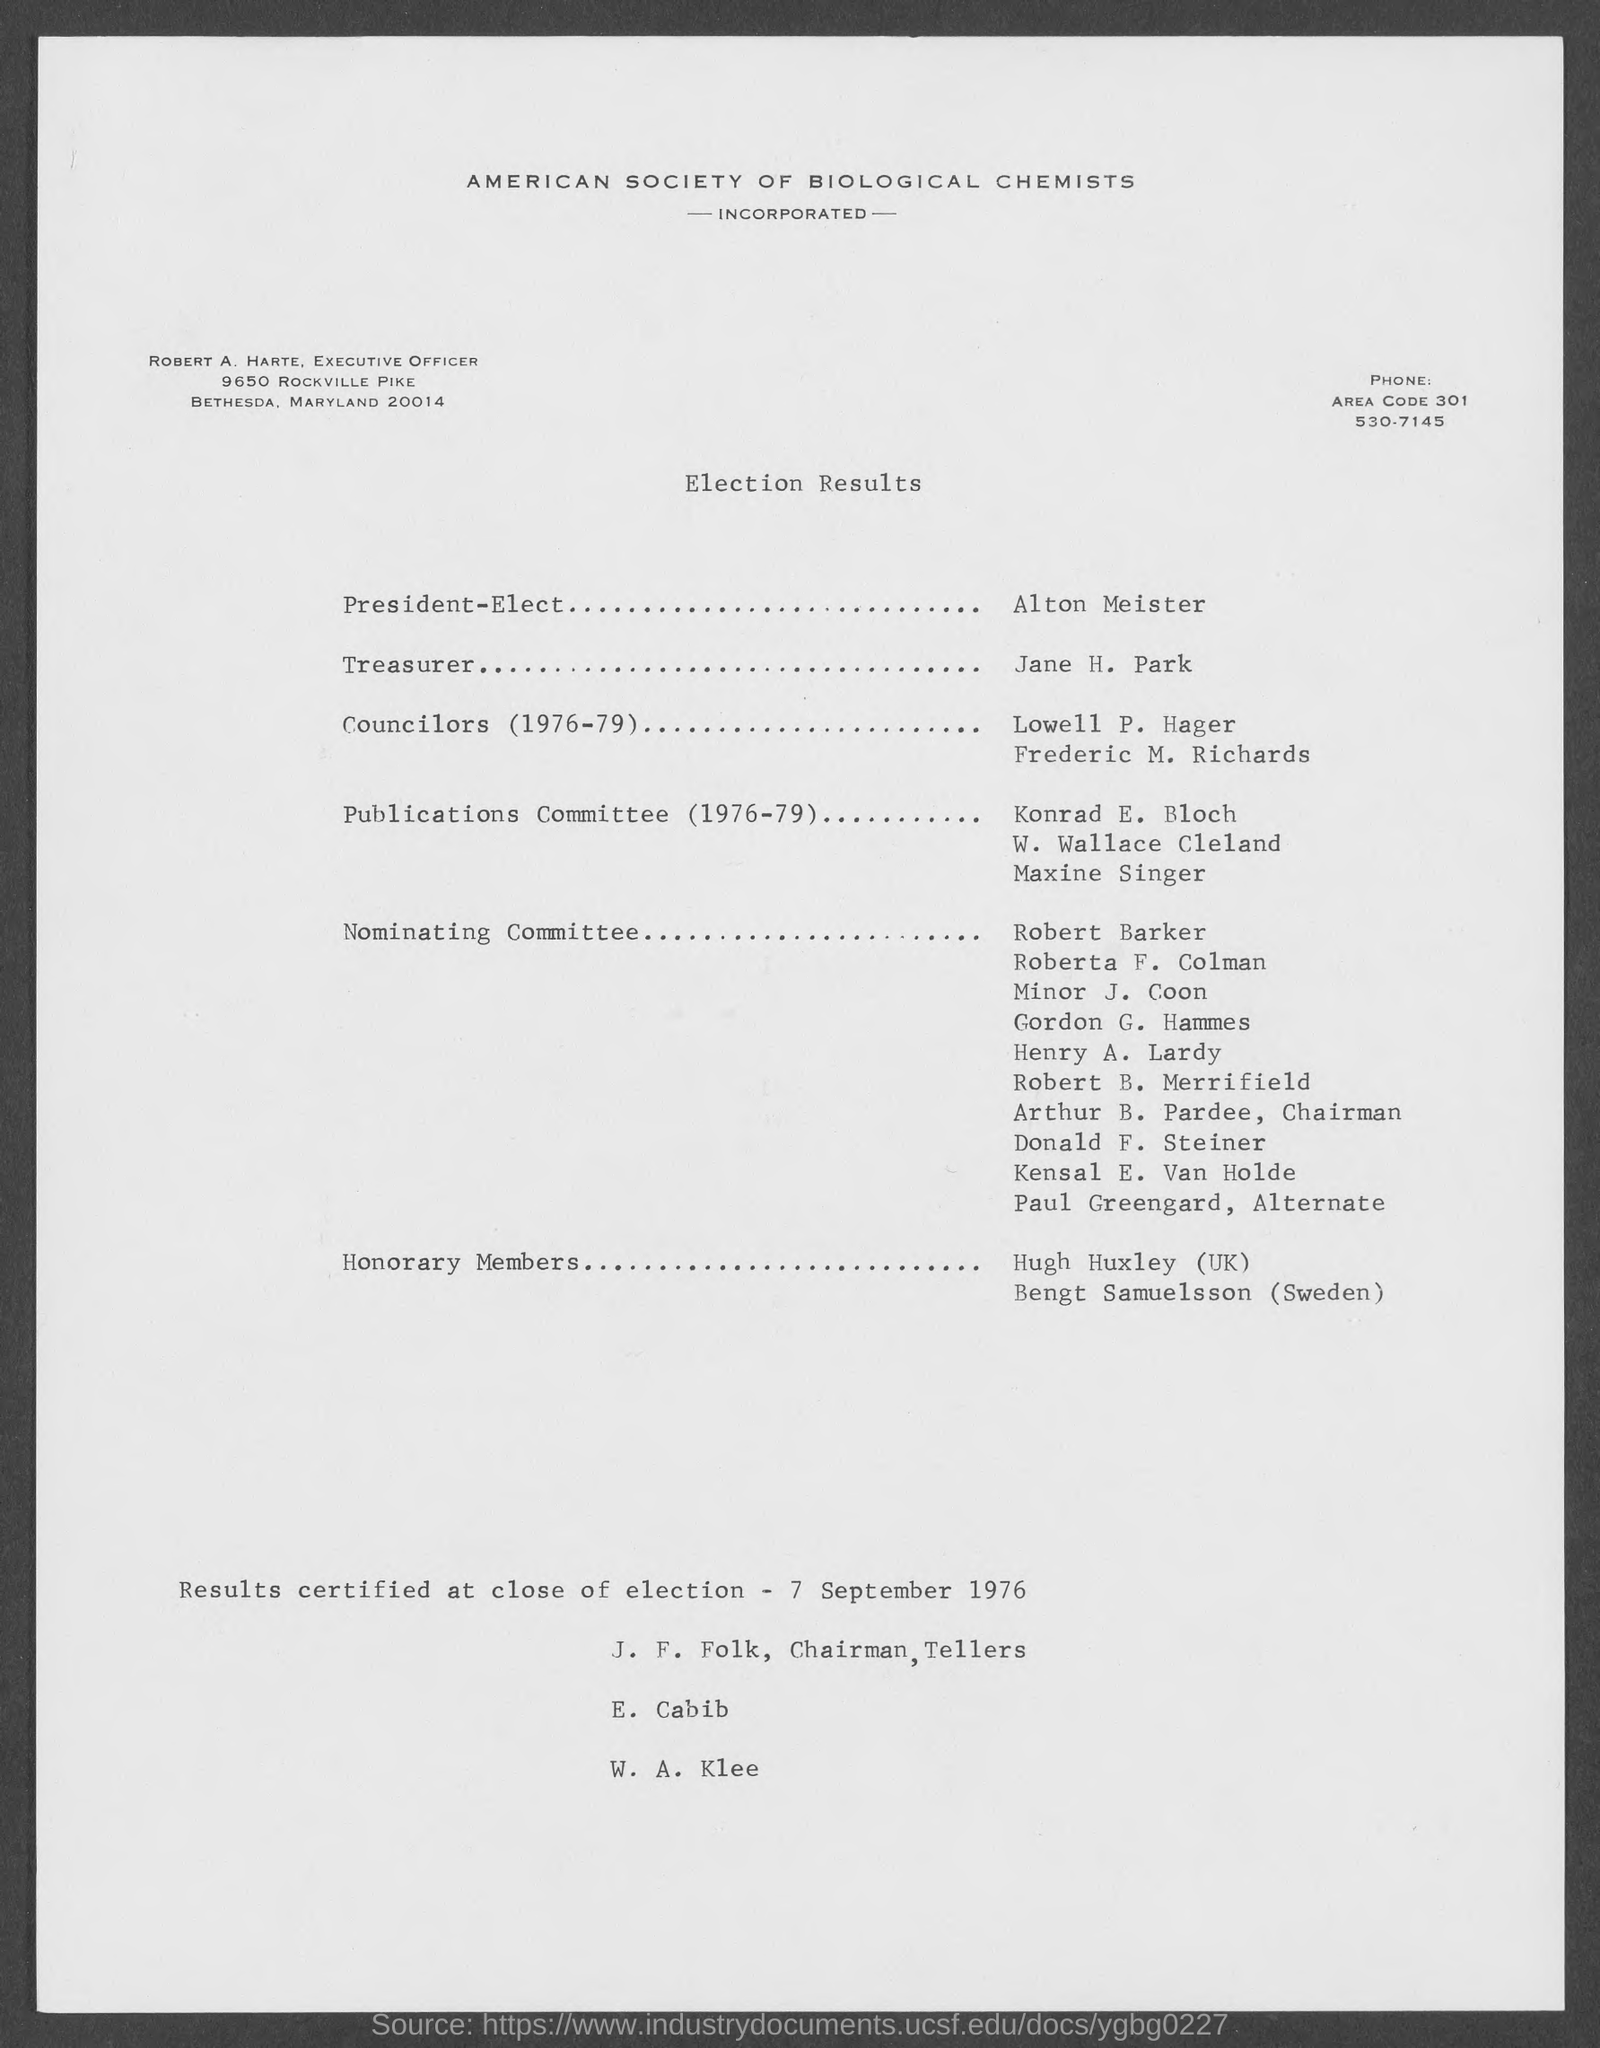List a handful of essential elements in this visual. Alton Meister is the President-Elect. The Treasurer's name is Jane H. Park. 